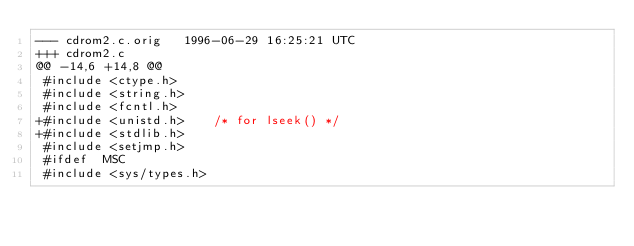<code> <loc_0><loc_0><loc_500><loc_500><_C_>--- cdrom2.c.orig	1996-06-29 16:25:21 UTC
+++ cdrom2.c
@@ -14,6 +14,8 @@
 #include <ctype.h>
 #include <string.h>
 #include <fcntl.h>
+#include <unistd.h>	/* for lseek() */
+#include <stdlib.h>
 #include <setjmp.h>
 #ifdef  MSC
 #include <sys/types.h>
</code> 